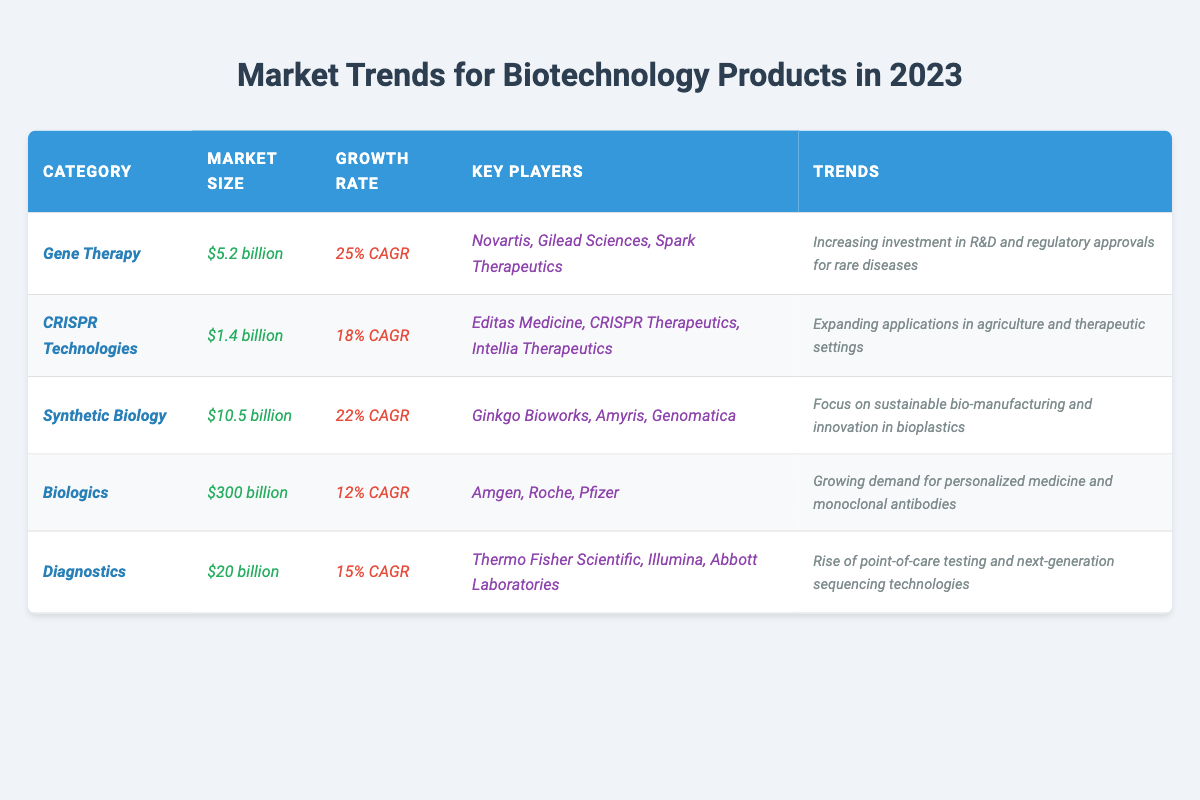What is the market size for Gene Therapy in 2023? The table lists the market size for the Gene Therapy category as $5.2 billion.
Answer: $5.2 billion Which biotechnology category has the highest market size? The table indicates that Biologics has the highest market size at $300 billion, compared to other categories.
Answer: Biologics What is the growth rate for CRISPR Technologies? According to the table, the growth rate for CRISPR Technologies is 18% CAGR.
Answer: 18% CAGR Are there more than three key players listed for the Synthetic Biology category? The table shows three key players for Synthetic Biology: Ginkgo Bioworks, Amyris, and Genomatica, so the answer is no.
Answer: No What is the combined market size of Gene Therapy and Diagnostics? The market size for Gene Therapy is $5.2 billion and for Diagnostics is $20 billion. Adding these gives $5.2 billion + $20 billion = $25.2 billion.
Answer: $25.2 billion Which category has a growth rate lower than the average growth rate of all categories? The growth rates are 25%, 18%, 22%, 12%, and 15%, which average out to (25 + 18 + 22 + 12 + 15)/5 = 18.4% CAGR. Biologics at 12% CAGR is the only category below this average.
Answer: Biologics Is there a trend focusing on sustainable bio-manufacturing? Yes, the Synthetic Biology category indicates a trend towards sustainable bio-manufacturing and innovation in bioplastics.
Answer: Yes Which category has the lowest growth rate, and what is it? The table indicates that Biologics has the lowest growth rate at 12% CAGR compared to other categories.
Answer: Biologics, 12% CAGR Name one key player in the Diagnostics category. The table lists several key players for Diagnostics, including Thermo Fisher Scientific, Illumina, and Abbott Laboratories; one example is Thermo Fisher Scientific.
Answer: Thermo Fisher Scientific How much larger is the market size for Biologics compared to CRISPR Technologies? Biologics has a market size of $300 billion, while CRISPR Technologies has a market size of $1.4 billion. The difference is $300 billion - $1.4 billion = $298.6 billion.
Answer: $298.6 billion 